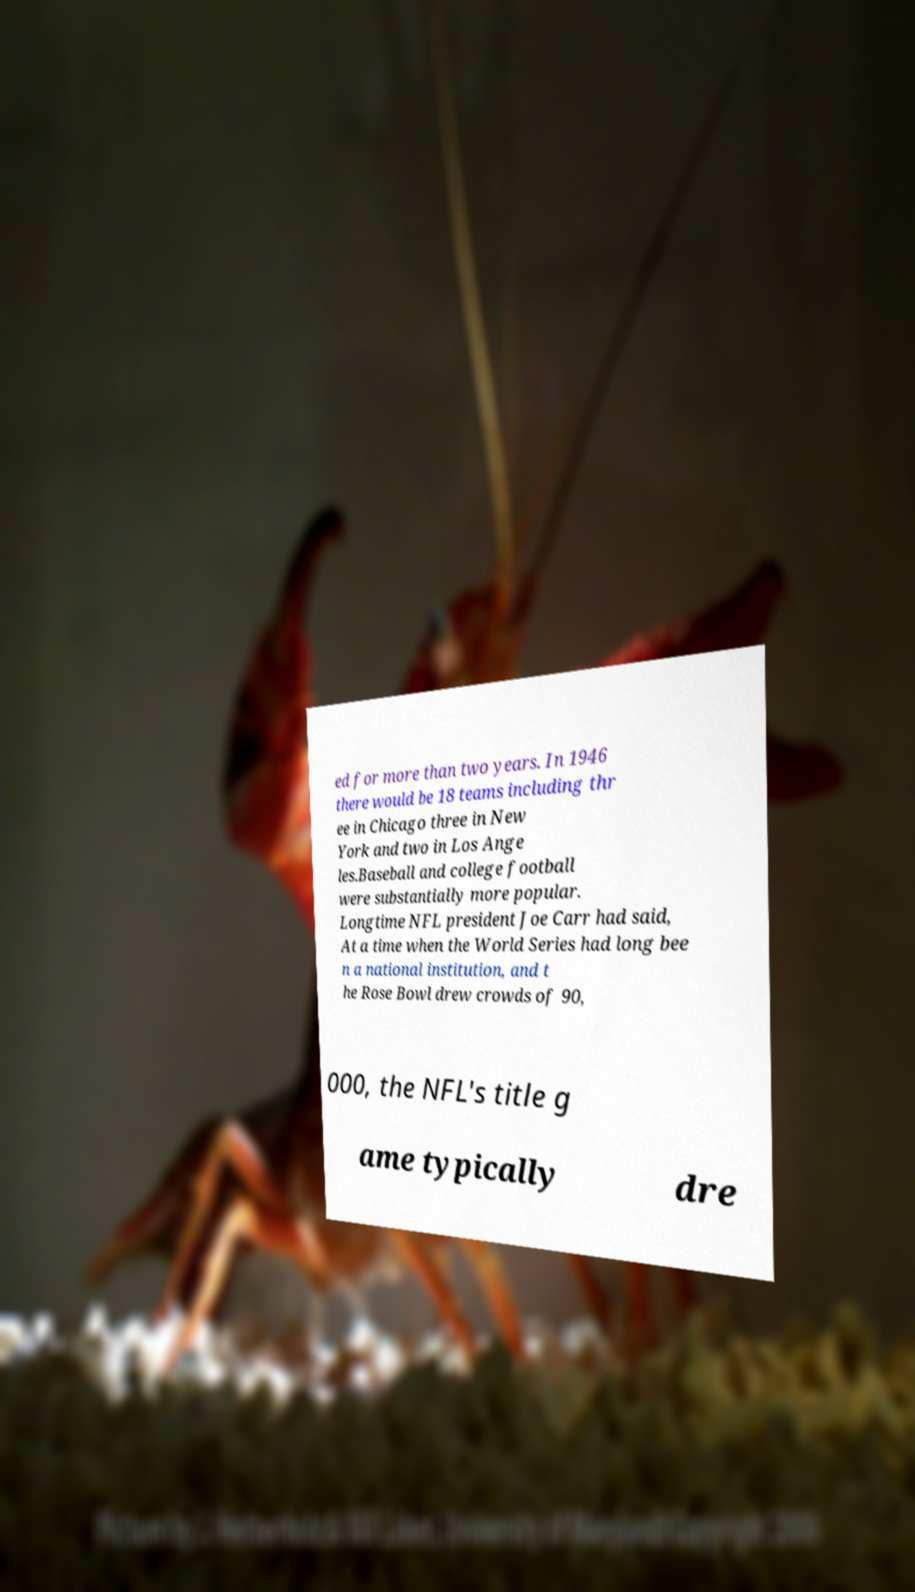Could you assist in decoding the text presented in this image and type it out clearly? ed for more than two years. In 1946 there would be 18 teams including thr ee in Chicago three in New York and two in Los Ange les.Baseball and college football were substantially more popular. Longtime NFL president Joe Carr had said, At a time when the World Series had long bee n a national institution, and t he Rose Bowl drew crowds of 90, 000, the NFL's title g ame typically dre 